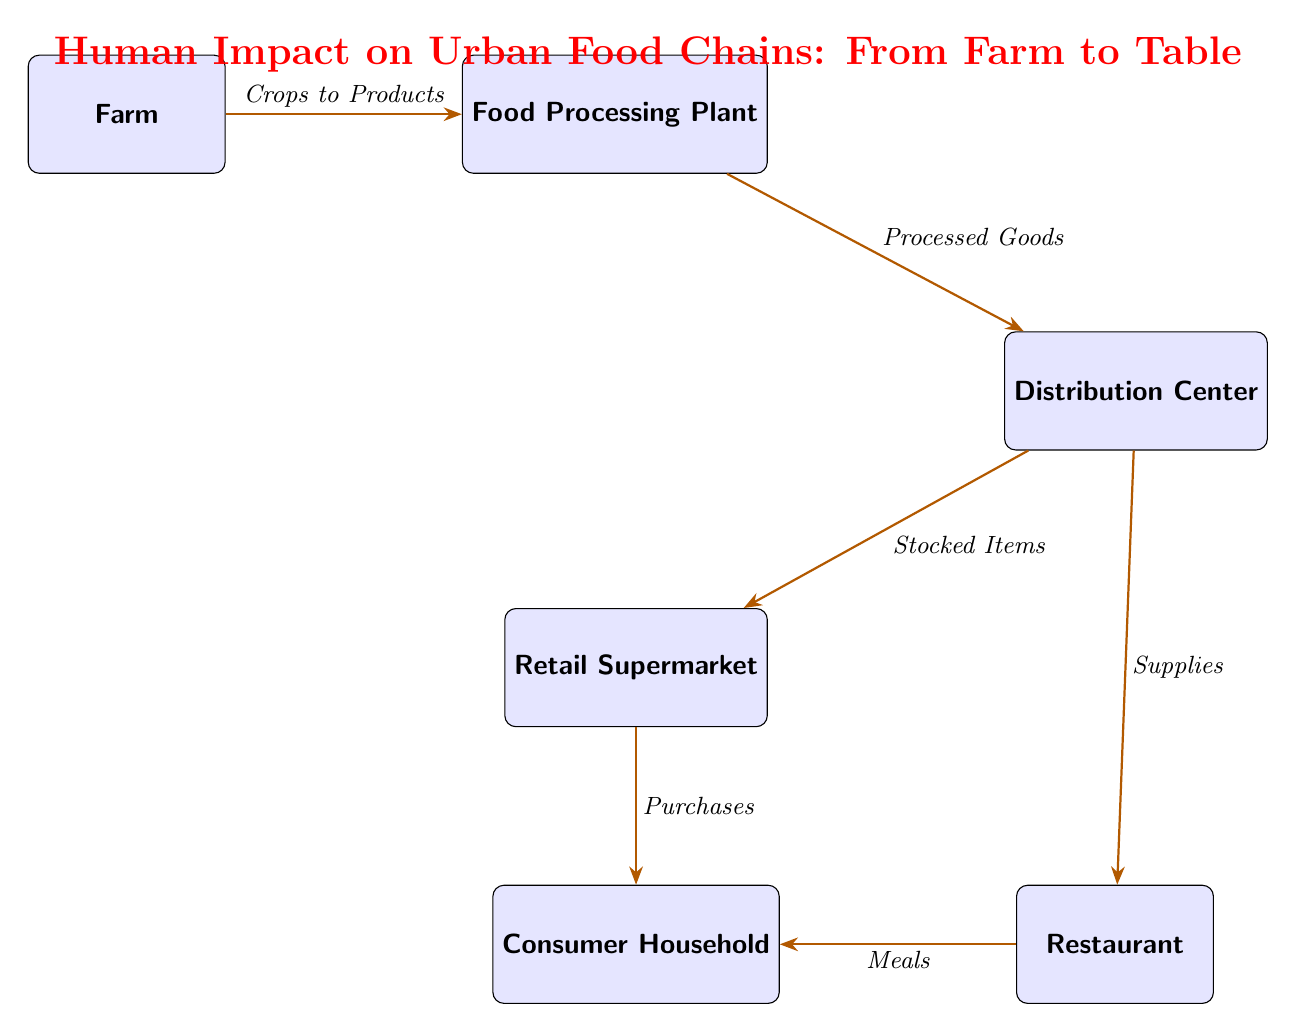What is the first node in the food chain? The first node in the food chain is labeled "Farm," which is where the process begins with the cultivation of crops.
Answer: Farm What type of goods move from the Food Processing Plant to the Distribution Center? The arrows in the diagram indicate that "Processed Goods" are the items that transition from the Food Processing Plant to the Distribution Center.
Answer: Processed Goods How many total nodes are present in the diagram? The diagram shows six nodes: Farm, Food Processing Plant, Distribution Center, Retail Supermarket, Consumer Household, and Restaurant. Therefore, the total number of nodes is six.
Answer: 6 What is the relationship between the Distribution Center and the Retail Supermarket? The arrow from the Distribution Center to the Retail Supermarket indicates that "Stocked Items" are the goods that flow in that direction, demonstrating the supply chain relationship.
Answer: Stocked Items What do Restaurant supplies to in the diagram? According to the connections illustrated, the Restaurant supplies "Meals" to the Consumer Household, showing the final step in the food chain before consumption.
Answer: Meals Which node receives Purchases from the Retail Supermarket? The Consumer Household receives "Purchases" from the Retail Supermarket, indicating the direct consumer transaction in the food chain.
Answer: Consumer Household What is the final destination for products originating from the Farm according to the food chain? The final destination for products that originate from the Farm, as represented in the food chain, is the "Consumer Household," where food products are eventually consumed.
Answer: Consumer Household What type of products flow from the Farm to the Food Processing Plant? The Farm to Food Processing Plant node indicates that "Crops to Products" are the type of outputs that travel from the first node to the second in the diagram.
Answer: Crops to Products 